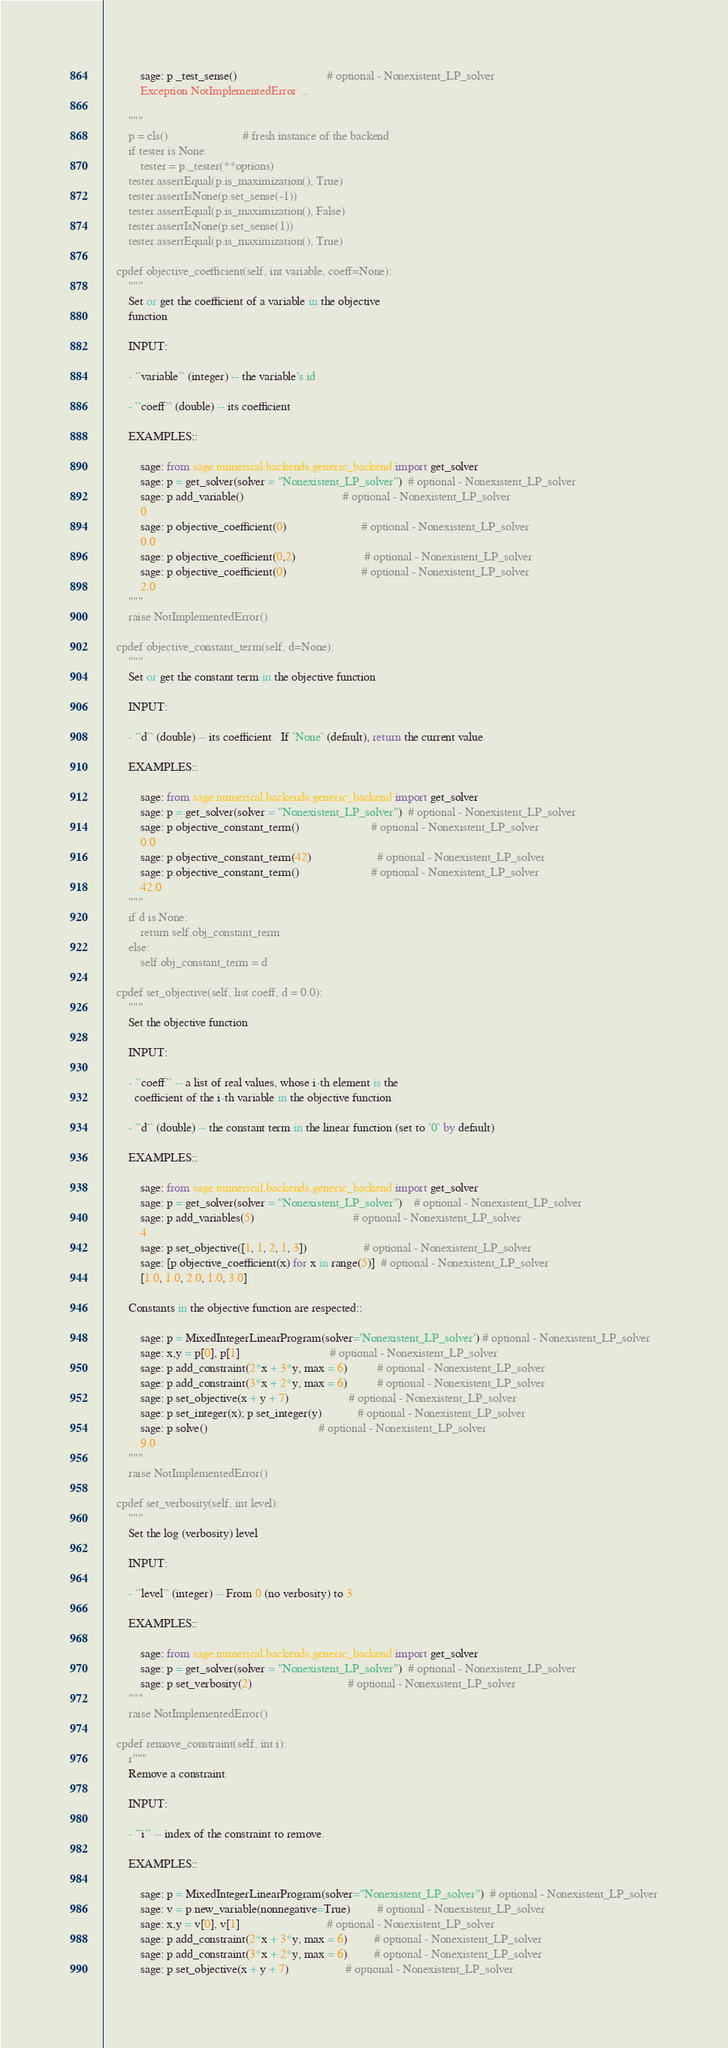<code> <loc_0><loc_0><loc_500><loc_500><_Cython_>            sage: p._test_sense()                              # optional - Nonexistent_LP_solver
            Exception NotImplementedError ...

        """
        p = cls()                         # fresh instance of the backend
        if tester is None:
            tester = p._tester(**options)
        tester.assertEqual(p.is_maximization(), True)
        tester.assertIsNone(p.set_sense(-1))
        tester.assertEqual(p.is_maximization(), False)
        tester.assertIsNone(p.set_sense(1))
        tester.assertEqual(p.is_maximization(), True)

    cpdef objective_coefficient(self, int variable, coeff=None):
        """
        Set or get the coefficient of a variable in the objective
        function

        INPUT:

        - ``variable`` (integer) -- the variable's id

        - ``coeff`` (double) -- its coefficient

        EXAMPLES::

            sage: from sage.numerical.backends.generic_backend import get_solver
            sage: p = get_solver(solver = "Nonexistent_LP_solver")  # optional - Nonexistent_LP_solver
            sage: p.add_variable()                                 # optional - Nonexistent_LP_solver
            0
            sage: p.objective_coefficient(0)                         # optional - Nonexistent_LP_solver
            0.0
            sage: p.objective_coefficient(0,2)                       # optional - Nonexistent_LP_solver
            sage: p.objective_coefficient(0)                         # optional - Nonexistent_LP_solver
            2.0
        """
        raise NotImplementedError()

    cpdef objective_constant_term(self, d=None):
        """
        Set or get the constant term in the objective function

        INPUT:

        - ``d`` (double) -- its coefficient.  If `None` (default), return the current value.

        EXAMPLES::

            sage: from sage.numerical.backends.generic_backend import get_solver
            sage: p = get_solver(solver = "Nonexistent_LP_solver")  # optional - Nonexistent_LP_solver
            sage: p.objective_constant_term()                        # optional - Nonexistent_LP_solver
            0.0
            sage: p.objective_constant_term(42)                      # optional - Nonexistent_LP_solver
            sage: p.objective_constant_term()                        # optional - Nonexistent_LP_solver
            42.0
        """
        if d is None:
            return self.obj_constant_term
        else:
            self.obj_constant_term = d

    cpdef set_objective(self, list coeff, d = 0.0):
        """
        Set the objective function.

        INPUT:

        - ``coeff`` -- a list of real values, whose i-th element is the
          coefficient of the i-th variable in the objective function.

        - ``d`` (double) -- the constant term in the linear function (set to `0` by default)

        EXAMPLES::

            sage: from sage.numerical.backends.generic_backend import get_solver
            sage: p = get_solver(solver = "Nonexistent_LP_solver")    # optional - Nonexistent_LP_solver
            sage: p.add_variables(5)                                 # optional - Nonexistent_LP_solver
            4
            sage: p.set_objective([1, 1, 2, 1, 3])                   # optional - Nonexistent_LP_solver
            sage: [p.objective_coefficient(x) for x in range(5)]  # optional - Nonexistent_LP_solver
            [1.0, 1.0, 2.0, 1.0, 3.0]

        Constants in the objective function are respected::

            sage: p = MixedIntegerLinearProgram(solver='Nonexistent_LP_solver') # optional - Nonexistent_LP_solver
            sage: x,y = p[0], p[1]                              # optional - Nonexistent_LP_solver
            sage: p.add_constraint(2*x + 3*y, max = 6)          # optional - Nonexistent_LP_solver
            sage: p.add_constraint(3*x + 2*y, max = 6)          # optional - Nonexistent_LP_solver
            sage: p.set_objective(x + y + 7)                    # optional - Nonexistent_LP_solver
            sage: p.set_integer(x); p.set_integer(y)            # optional - Nonexistent_LP_solver
            sage: p.solve()                                     # optional - Nonexistent_LP_solver
            9.0
        """
        raise NotImplementedError()

    cpdef set_verbosity(self, int level):
        """
        Set the log (verbosity) level

        INPUT:

        - ``level`` (integer) -- From 0 (no verbosity) to 3.

        EXAMPLES::

            sage: from sage.numerical.backends.generic_backend import get_solver
            sage: p = get_solver(solver = "Nonexistent_LP_solver")  # optional - Nonexistent_LP_solver
            sage: p.set_verbosity(2)                                # optional - Nonexistent_LP_solver
        """
        raise NotImplementedError()

    cpdef remove_constraint(self, int i):
        r"""
        Remove a constraint.

        INPUT:

        - ``i`` -- index of the constraint to remove.

        EXAMPLES::

            sage: p = MixedIntegerLinearProgram(solver="Nonexistent_LP_solver")  # optional - Nonexistent_LP_solver
            sage: v = p.new_variable(nonnegative=True)         # optional - Nonexistent_LP_solver
            sage: x,y = v[0], v[1]                             # optional - Nonexistent_LP_solver
            sage: p.add_constraint(2*x + 3*y, max = 6)         # optional - Nonexistent_LP_solver
            sage: p.add_constraint(3*x + 2*y, max = 6)         # optional - Nonexistent_LP_solver
            sage: p.set_objective(x + y + 7)                   # optional - Nonexistent_LP_solver</code> 